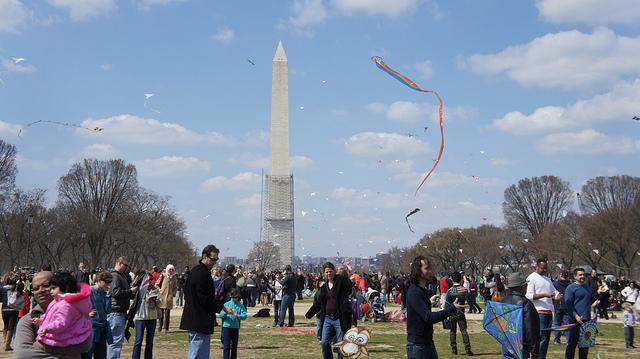Can you pick out the largest kite in this picture?
Answer briefly. Yes. What is the monument in the background?
Write a very short answer. Washington monument. What are these people standing in front of?
Short answer required. Monument. What are the objects flying in the sky?
Quick response, please. Kites. Where are they?
Give a very brief answer. Washington dc. 